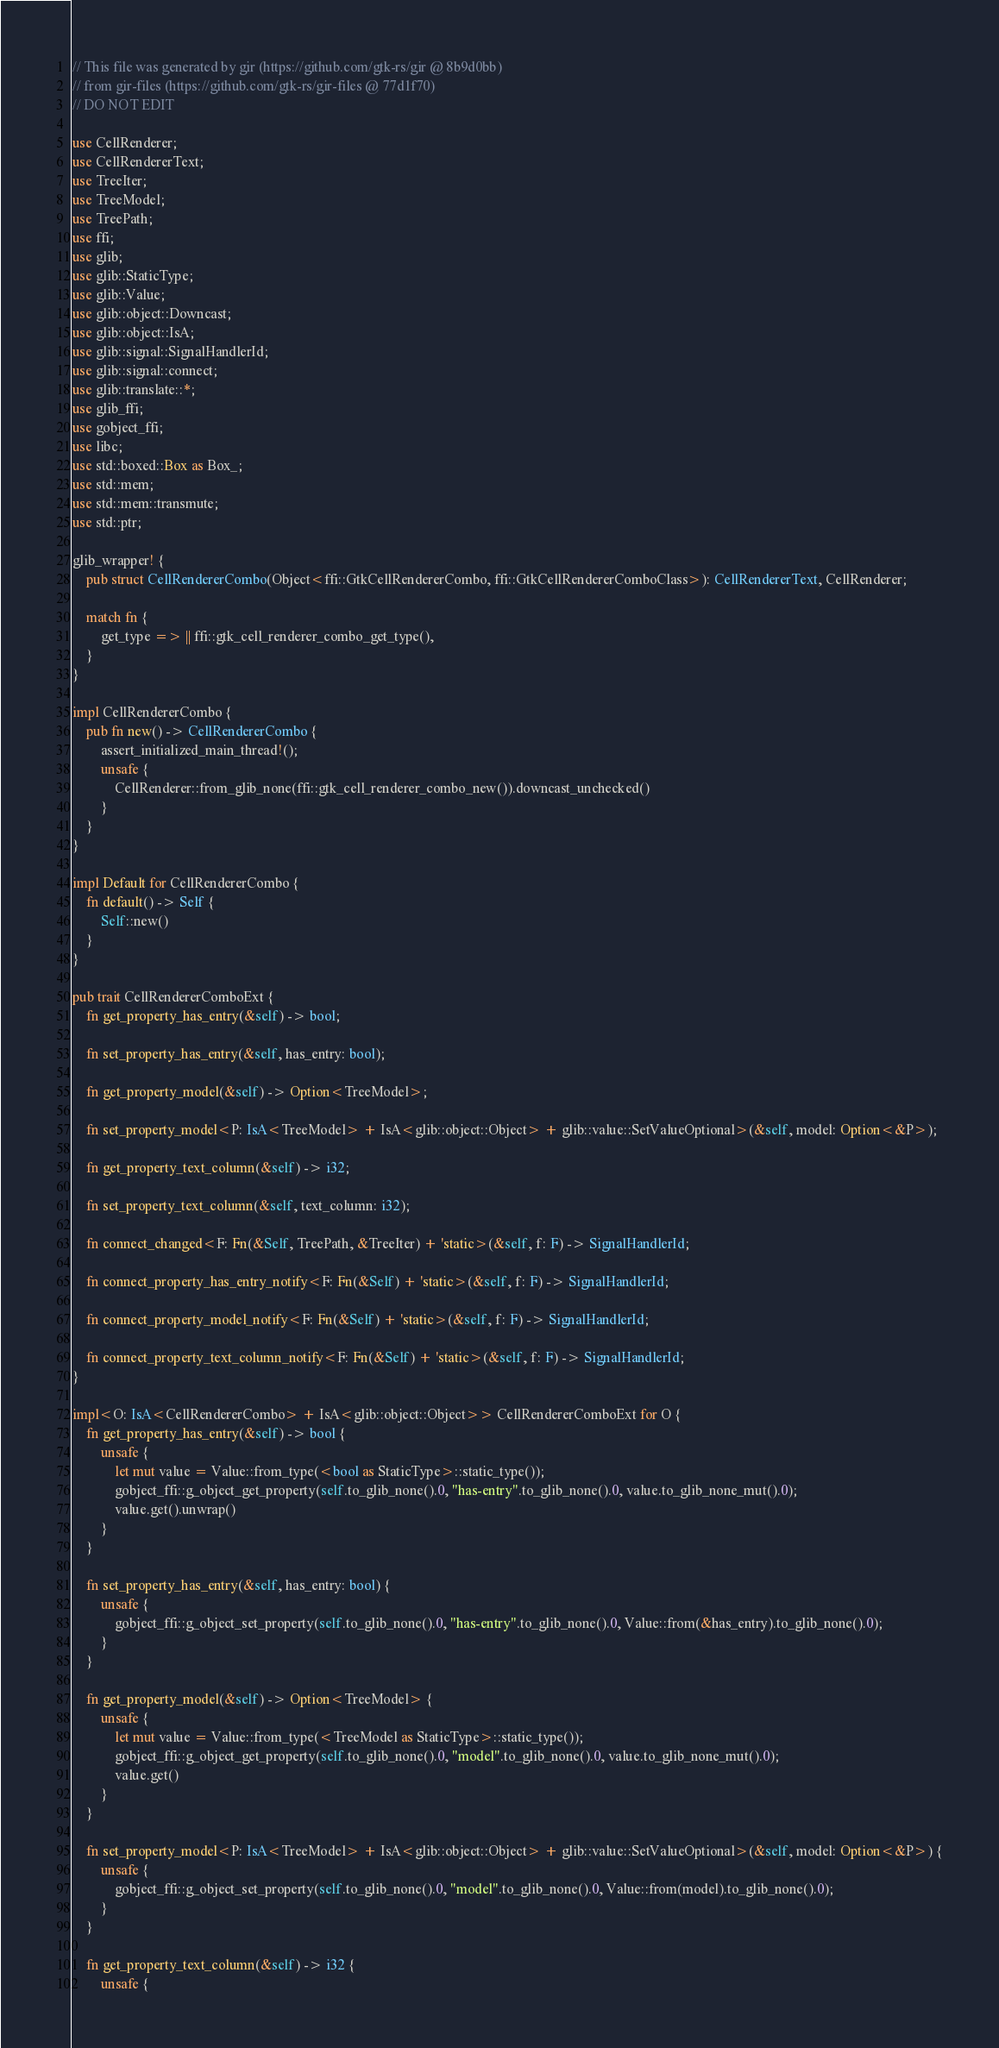<code> <loc_0><loc_0><loc_500><loc_500><_Rust_>// This file was generated by gir (https://github.com/gtk-rs/gir @ 8b9d0bb)
// from gir-files (https://github.com/gtk-rs/gir-files @ 77d1f70)
// DO NOT EDIT

use CellRenderer;
use CellRendererText;
use TreeIter;
use TreeModel;
use TreePath;
use ffi;
use glib;
use glib::StaticType;
use glib::Value;
use glib::object::Downcast;
use glib::object::IsA;
use glib::signal::SignalHandlerId;
use glib::signal::connect;
use glib::translate::*;
use glib_ffi;
use gobject_ffi;
use libc;
use std::boxed::Box as Box_;
use std::mem;
use std::mem::transmute;
use std::ptr;

glib_wrapper! {
    pub struct CellRendererCombo(Object<ffi::GtkCellRendererCombo, ffi::GtkCellRendererComboClass>): CellRendererText, CellRenderer;

    match fn {
        get_type => || ffi::gtk_cell_renderer_combo_get_type(),
    }
}

impl CellRendererCombo {
    pub fn new() -> CellRendererCombo {
        assert_initialized_main_thread!();
        unsafe {
            CellRenderer::from_glib_none(ffi::gtk_cell_renderer_combo_new()).downcast_unchecked()
        }
    }
}

impl Default for CellRendererCombo {
    fn default() -> Self {
        Self::new()
    }
}

pub trait CellRendererComboExt {
    fn get_property_has_entry(&self) -> bool;

    fn set_property_has_entry(&self, has_entry: bool);

    fn get_property_model(&self) -> Option<TreeModel>;

    fn set_property_model<P: IsA<TreeModel> + IsA<glib::object::Object> + glib::value::SetValueOptional>(&self, model: Option<&P>);

    fn get_property_text_column(&self) -> i32;

    fn set_property_text_column(&self, text_column: i32);

    fn connect_changed<F: Fn(&Self, TreePath, &TreeIter) + 'static>(&self, f: F) -> SignalHandlerId;

    fn connect_property_has_entry_notify<F: Fn(&Self) + 'static>(&self, f: F) -> SignalHandlerId;

    fn connect_property_model_notify<F: Fn(&Self) + 'static>(&self, f: F) -> SignalHandlerId;

    fn connect_property_text_column_notify<F: Fn(&Self) + 'static>(&self, f: F) -> SignalHandlerId;
}

impl<O: IsA<CellRendererCombo> + IsA<glib::object::Object>> CellRendererComboExt for O {
    fn get_property_has_entry(&self) -> bool {
        unsafe {
            let mut value = Value::from_type(<bool as StaticType>::static_type());
            gobject_ffi::g_object_get_property(self.to_glib_none().0, "has-entry".to_glib_none().0, value.to_glib_none_mut().0);
            value.get().unwrap()
        }
    }

    fn set_property_has_entry(&self, has_entry: bool) {
        unsafe {
            gobject_ffi::g_object_set_property(self.to_glib_none().0, "has-entry".to_glib_none().0, Value::from(&has_entry).to_glib_none().0);
        }
    }

    fn get_property_model(&self) -> Option<TreeModel> {
        unsafe {
            let mut value = Value::from_type(<TreeModel as StaticType>::static_type());
            gobject_ffi::g_object_get_property(self.to_glib_none().0, "model".to_glib_none().0, value.to_glib_none_mut().0);
            value.get()
        }
    }

    fn set_property_model<P: IsA<TreeModel> + IsA<glib::object::Object> + glib::value::SetValueOptional>(&self, model: Option<&P>) {
        unsafe {
            gobject_ffi::g_object_set_property(self.to_glib_none().0, "model".to_glib_none().0, Value::from(model).to_glib_none().0);
        }
    }

    fn get_property_text_column(&self) -> i32 {
        unsafe {</code> 